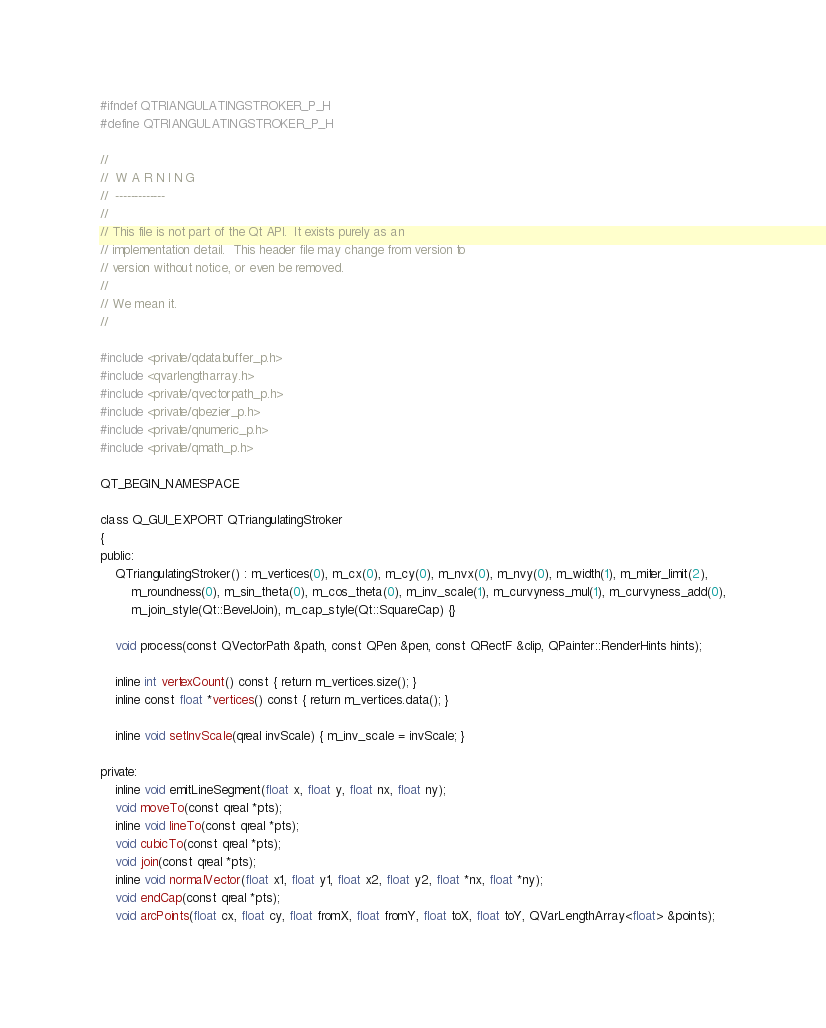<code> <loc_0><loc_0><loc_500><loc_500><_C_>#ifndef QTRIANGULATINGSTROKER_P_H
#define QTRIANGULATINGSTROKER_P_H

//
//  W A R N I N G
//  -------------
//
// This file is not part of the Qt API.  It exists purely as an
// implementation detail.  This header file may change from version to
// version without notice, or even be removed.
//
// We mean it.
//

#include <private/qdatabuffer_p.h>
#include <qvarlengtharray.h>
#include <private/qvectorpath_p.h>
#include <private/qbezier_p.h>
#include <private/qnumeric_p.h>
#include <private/qmath_p.h>

QT_BEGIN_NAMESPACE

class Q_GUI_EXPORT QTriangulatingStroker
{
public:
    QTriangulatingStroker() : m_vertices(0), m_cx(0), m_cy(0), m_nvx(0), m_nvy(0), m_width(1), m_miter_limit(2),
        m_roundness(0), m_sin_theta(0), m_cos_theta(0), m_inv_scale(1), m_curvyness_mul(1), m_curvyness_add(0),
        m_join_style(Qt::BevelJoin), m_cap_style(Qt::SquareCap) {}

    void process(const QVectorPath &path, const QPen &pen, const QRectF &clip, QPainter::RenderHints hints);

    inline int vertexCount() const { return m_vertices.size(); }
    inline const float *vertices() const { return m_vertices.data(); }

    inline void setInvScale(qreal invScale) { m_inv_scale = invScale; }

private:
    inline void emitLineSegment(float x, float y, float nx, float ny);
    void moveTo(const qreal *pts);
    inline void lineTo(const qreal *pts);
    void cubicTo(const qreal *pts);
    void join(const qreal *pts);
    inline void normalVector(float x1, float y1, float x2, float y2, float *nx, float *ny);
    void endCap(const qreal *pts);
    void arcPoints(float cx, float cy, float fromX, float fromY, float toX, float toY, QVarLengthArray<float> &points);</code> 